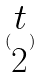<formula> <loc_0><loc_0><loc_500><loc_500>( \begin{matrix} t \\ 2 \end{matrix} )</formula> 